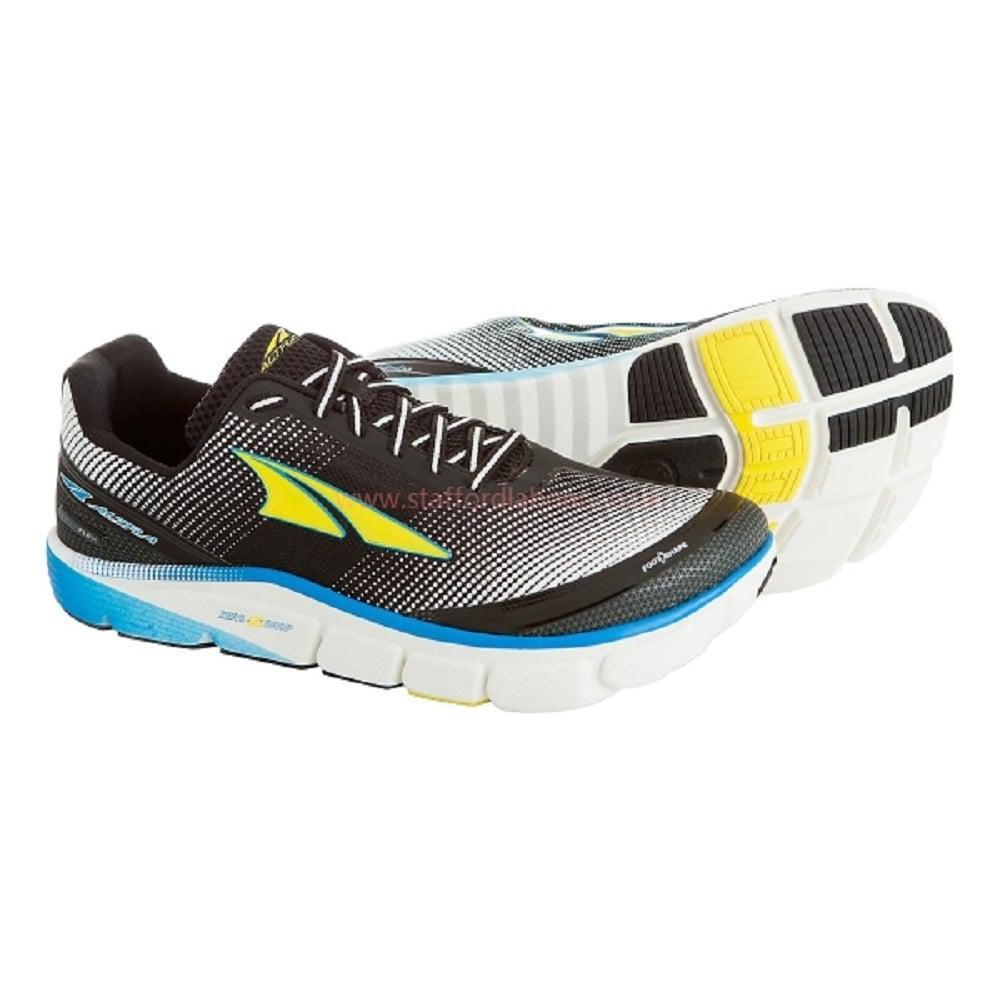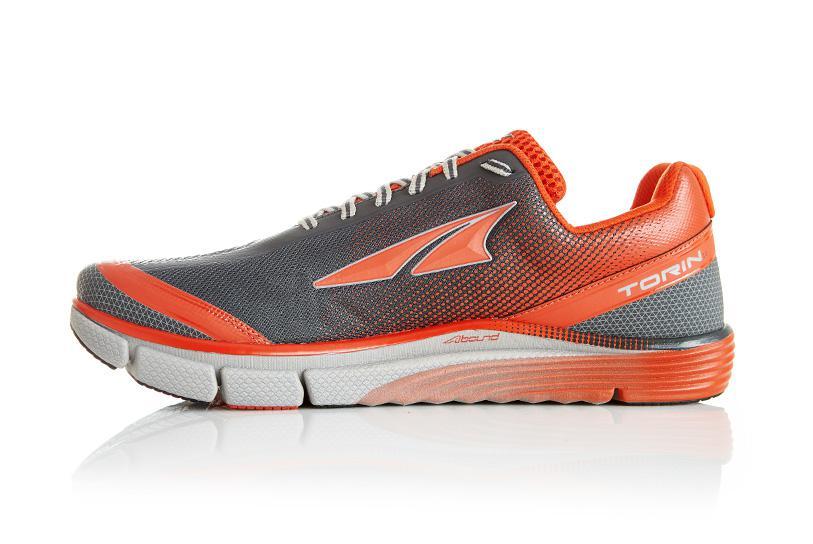The first image is the image on the left, the second image is the image on the right. For the images displayed, is the sentence "All shoes face rightward and all shoes are displayed without their matched partner." factually correct? Answer yes or no. No. The first image is the image on the left, the second image is the image on the right. Given the left and right images, does the statement "There is exactly two sports tennis shoes in the left image." hold true? Answer yes or no. Yes. 